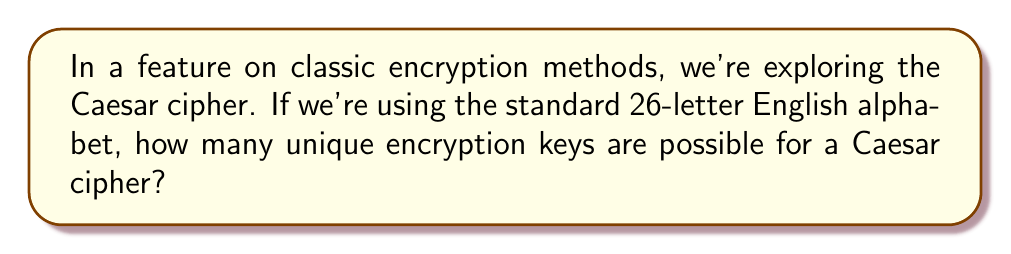Can you solve this math problem? Let's break this down step-by-step:

1) The Caesar cipher works by shifting each letter in the plaintext by a fixed number of positions in the alphabet.

2) The number of possible shifts is equal to the number of letters in the alphabet, which is 26 for the standard English alphabet.

3) However, we need to consider that:
   a) Shifting by 0 positions doesn't change the text, but it's still a valid key.
   b) Shifting by 26 positions is equivalent to shifting by 0 positions.

4) Therefore, the number of unique encryption keys is:

   $$26 - 1 = 25$$

5) We subtract 1 because the shift of 26 is equivalent to the shift of 0, so we don't count it separately.

This means there are 25 unique ways to encrypt a message using a Caesar cipher with the standard English alphabet.
Answer: 25 